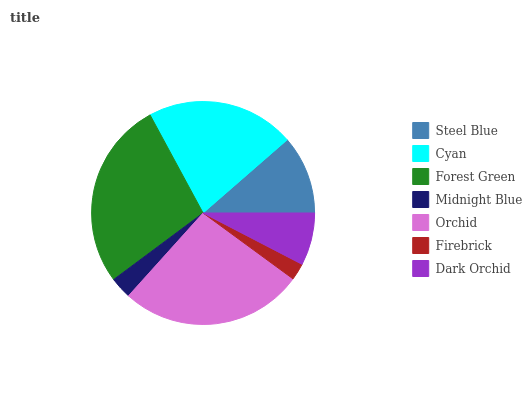Is Firebrick the minimum?
Answer yes or no. Yes. Is Forest Green the maximum?
Answer yes or no. Yes. Is Cyan the minimum?
Answer yes or no. No. Is Cyan the maximum?
Answer yes or no. No. Is Cyan greater than Steel Blue?
Answer yes or no. Yes. Is Steel Blue less than Cyan?
Answer yes or no. Yes. Is Steel Blue greater than Cyan?
Answer yes or no. No. Is Cyan less than Steel Blue?
Answer yes or no. No. Is Steel Blue the high median?
Answer yes or no. Yes. Is Steel Blue the low median?
Answer yes or no. Yes. Is Firebrick the high median?
Answer yes or no. No. Is Forest Green the low median?
Answer yes or no. No. 